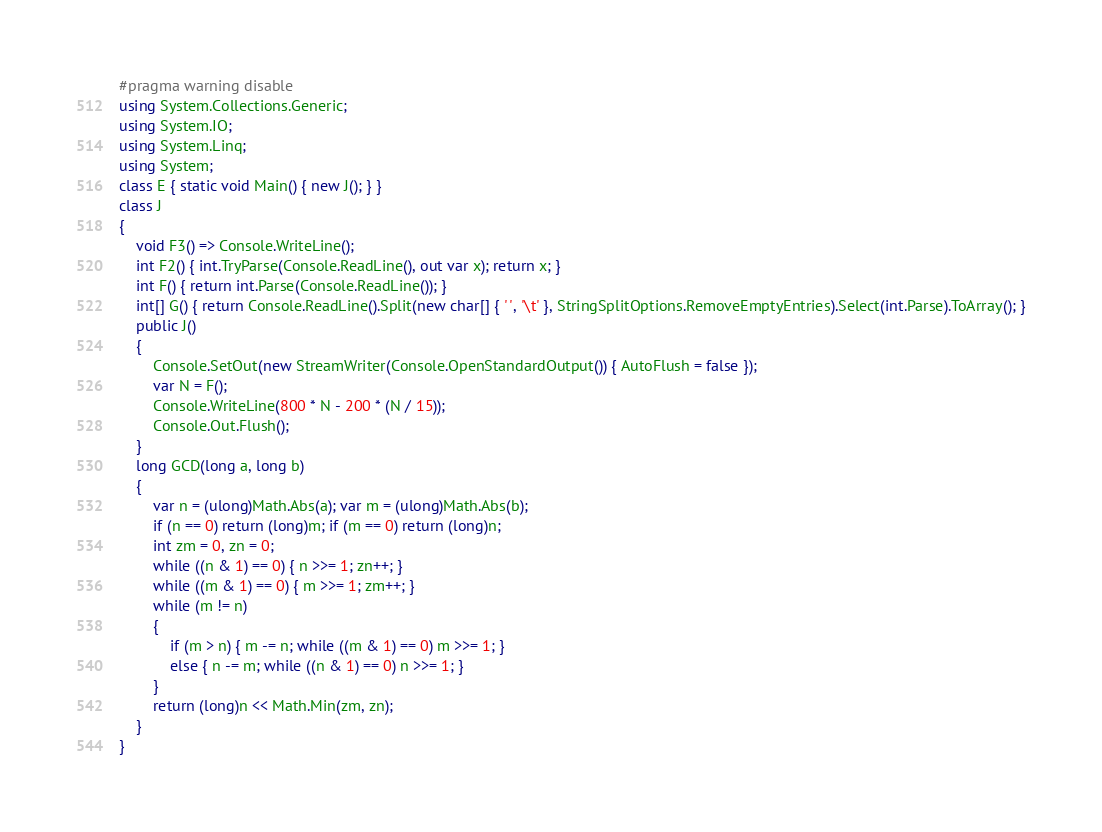Convert code to text. <code><loc_0><loc_0><loc_500><loc_500><_C#_>#pragma warning disable
using System.Collections.Generic;
using System.IO;
using System.Linq;
using System;
class E { static void Main() { new J(); } }
class J
{
	void F3() => Console.WriteLine();
	int F2() { int.TryParse(Console.ReadLine(), out var x); return x; }
	int F() { return int.Parse(Console.ReadLine()); }
	int[] G() { return Console.ReadLine().Split(new char[] { ' ', '\t' }, StringSplitOptions.RemoveEmptyEntries).Select(int.Parse).ToArray(); }
	public J()
	{
		Console.SetOut(new StreamWriter(Console.OpenStandardOutput()) { AutoFlush = false });
		var N = F();
		Console.WriteLine(800 * N - 200 * (N / 15));
		Console.Out.Flush();
	}
	long GCD(long a, long b)
	{
		var n = (ulong)Math.Abs(a); var m = (ulong)Math.Abs(b);
		if (n == 0) return (long)m; if (m == 0) return (long)n;
		int zm = 0, zn = 0;
		while ((n & 1) == 0) { n >>= 1; zn++; }
		while ((m & 1) == 0) { m >>= 1; zm++; }
		while (m != n)
		{
			if (m > n) { m -= n; while ((m & 1) == 0) m >>= 1; }
			else { n -= m; while ((n & 1) == 0) n >>= 1; }
		}
		return (long)n << Math.Min(zm, zn);
	}
}</code> 